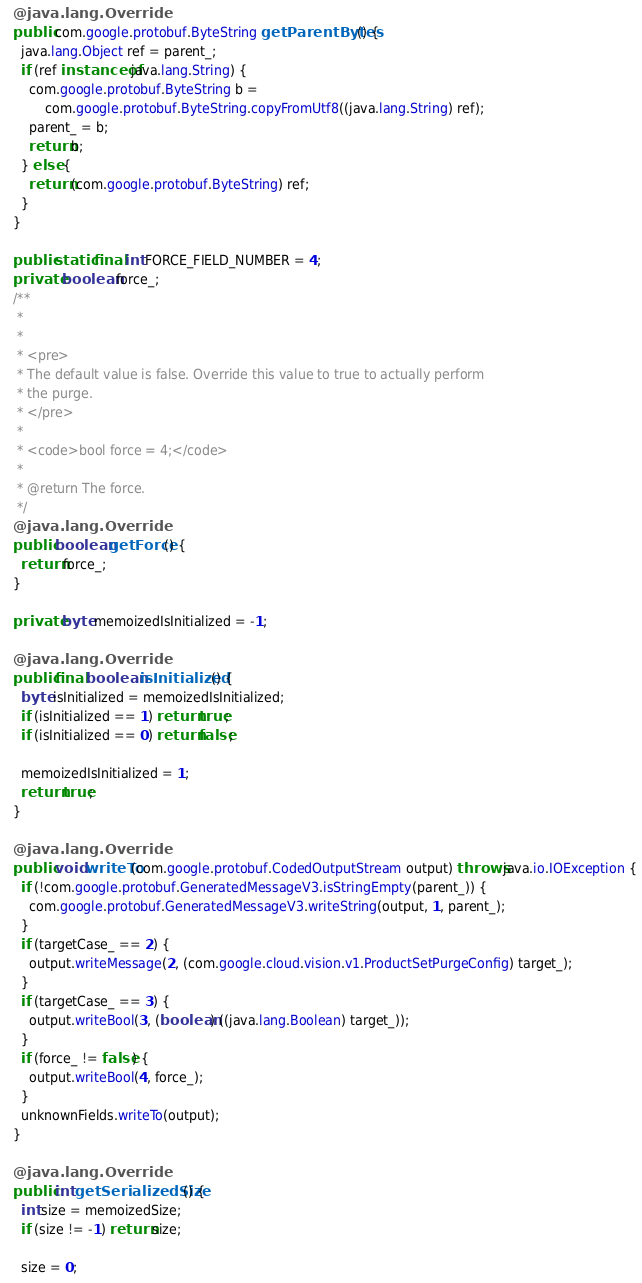<code> <loc_0><loc_0><loc_500><loc_500><_Java_>  @java.lang.Override
  public com.google.protobuf.ByteString getParentBytes() {
    java.lang.Object ref = parent_;
    if (ref instanceof java.lang.String) {
      com.google.protobuf.ByteString b =
          com.google.protobuf.ByteString.copyFromUtf8((java.lang.String) ref);
      parent_ = b;
      return b;
    } else {
      return (com.google.protobuf.ByteString) ref;
    }
  }

  public static final int FORCE_FIELD_NUMBER = 4;
  private boolean force_;
  /**
   *
   *
   * <pre>
   * The default value is false. Override this value to true to actually perform
   * the purge.
   * </pre>
   *
   * <code>bool force = 4;</code>
   *
   * @return The force.
   */
  @java.lang.Override
  public boolean getForce() {
    return force_;
  }

  private byte memoizedIsInitialized = -1;

  @java.lang.Override
  public final boolean isInitialized() {
    byte isInitialized = memoizedIsInitialized;
    if (isInitialized == 1) return true;
    if (isInitialized == 0) return false;

    memoizedIsInitialized = 1;
    return true;
  }

  @java.lang.Override
  public void writeTo(com.google.protobuf.CodedOutputStream output) throws java.io.IOException {
    if (!com.google.protobuf.GeneratedMessageV3.isStringEmpty(parent_)) {
      com.google.protobuf.GeneratedMessageV3.writeString(output, 1, parent_);
    }
    if (targetCase_ == 2) {
      output.writeMessage(2, (com.google.cloud.vision.v1.ProductSetPurgeConfig) target_);
    }
    if (targetCase_ == 3) {
      output.writeBool(3, (boolean) ((java.lang.Boolean) target_));
    }
    if (force_ != false) {
      output.writeBool(4, force_);
    }
    unknownFields.writeTo(output);
  }

  @java.lang.Override
  public int getSerializedSize() {
    int size = memoizedSize;
    if (size != -1) return size;

    size = 0;</code> 